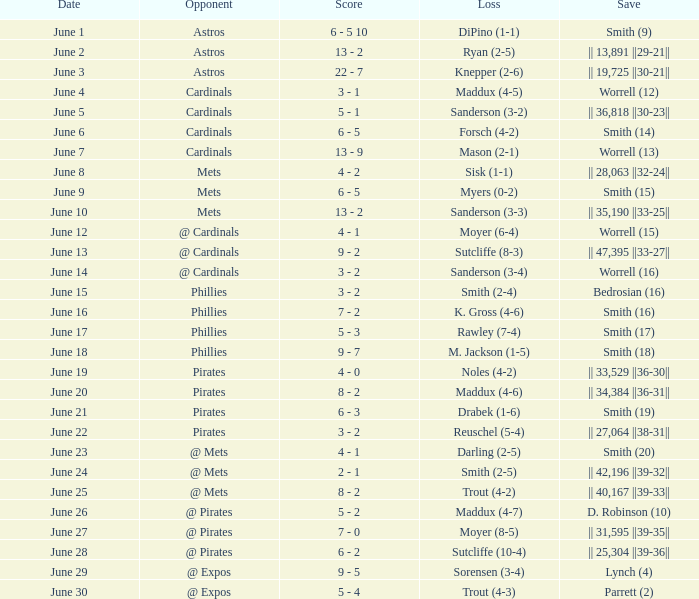What is the loss for the game against @ expos, with a save of parrett (2)? Trout (4-3). 